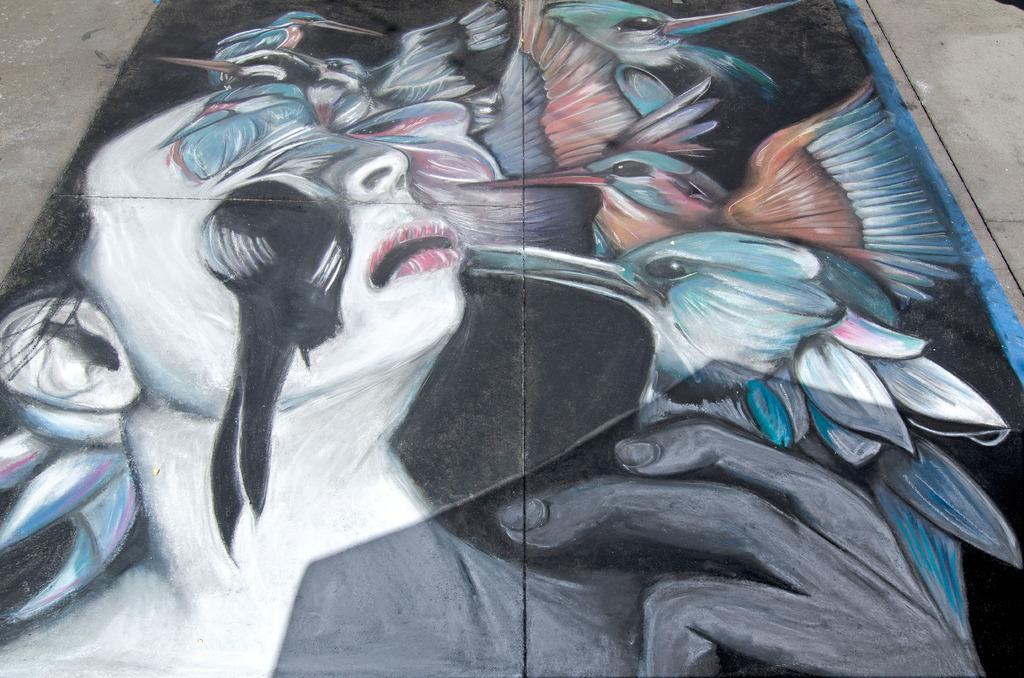In one or two sentences, can you explain what this image depicts? In this picture I can see the painting of a person and few birds. 